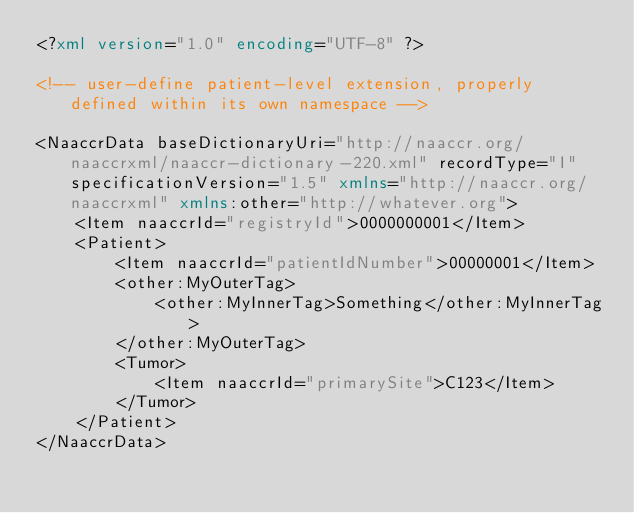Convert code to text. <code><loc_0><loc_0><loc_500><loc_500><_XML_><?xml version="1.0" encoding="UTF-8" ?>

<!-- user-define patient-level extension, properly defined within its own namespace -->

<NaaccrData baseDictionaryUri="http://naaccr.org/naaccrxml/naaccr-dictionary-220.xml" recordType="I" specificationVersion="1.5" xmlns="http://naaccr.org/naaccrxml" xmlns:other="http://whatever.org">
    <Item naaccrId="registryId">0000000001</Item>
    <Patient>
        <Item naaccrId="patientIdNumber">00000001</Item>
        <other:MyOuterTag>
            <other:MyInnerTag>Something</other:MyInnerTag>
        </other:MyOuterTag>
        <Tumor>
            <Item naaccrId="primarySite">C123</Item>
        </Tumor>
    </Patient>
</NaaccrData></code> 